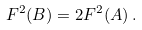Convert formula to latex. <formula><loc_0><loc_0><loc_500><loc_500>F ^ { 2 } ( B ) = 2 F ^ { 2 } ( A ) \, .</formula> 